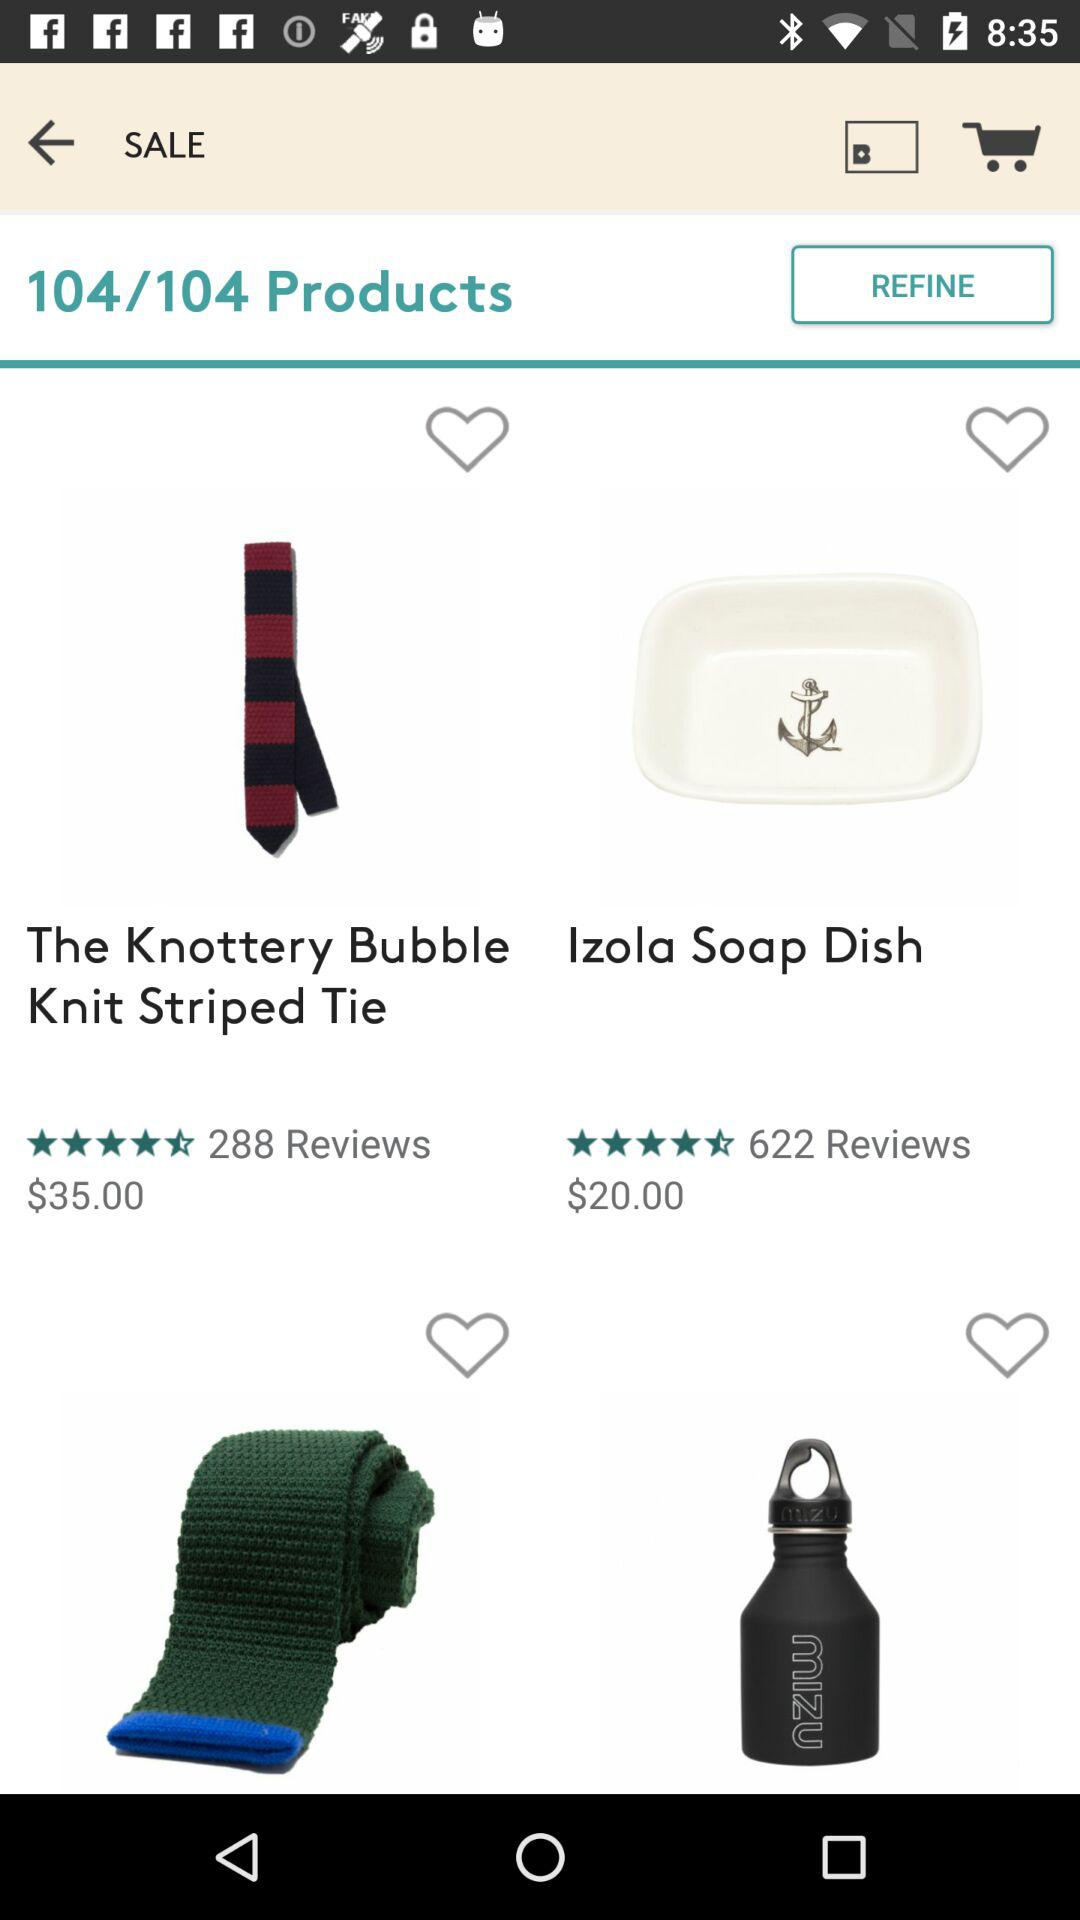How many reviews are there for the "Izola Soap Dish"? There are 622 reviews for the "Izola Soap Dish". 